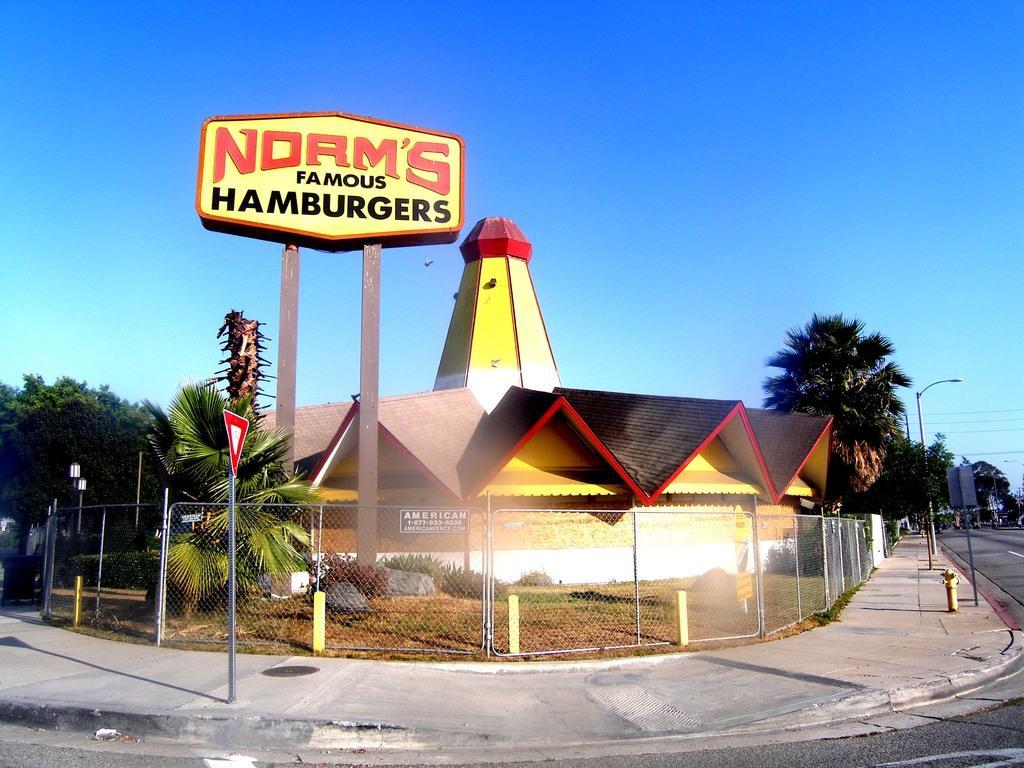Could you give a brief overview of what you see in this image? In this picture we can see the road, footpath, signboard, poles, trees, wires, fence, house and in the background we can see the sky. 